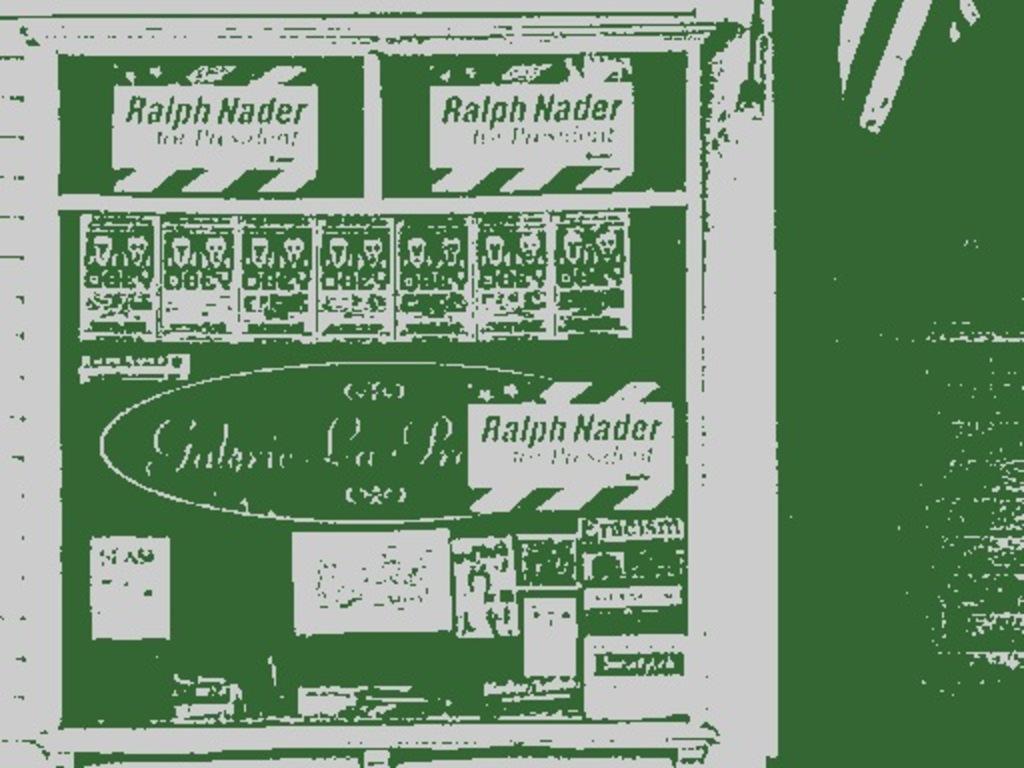Who's name is on the green board?
Offer a terse response. Ralph nader. 